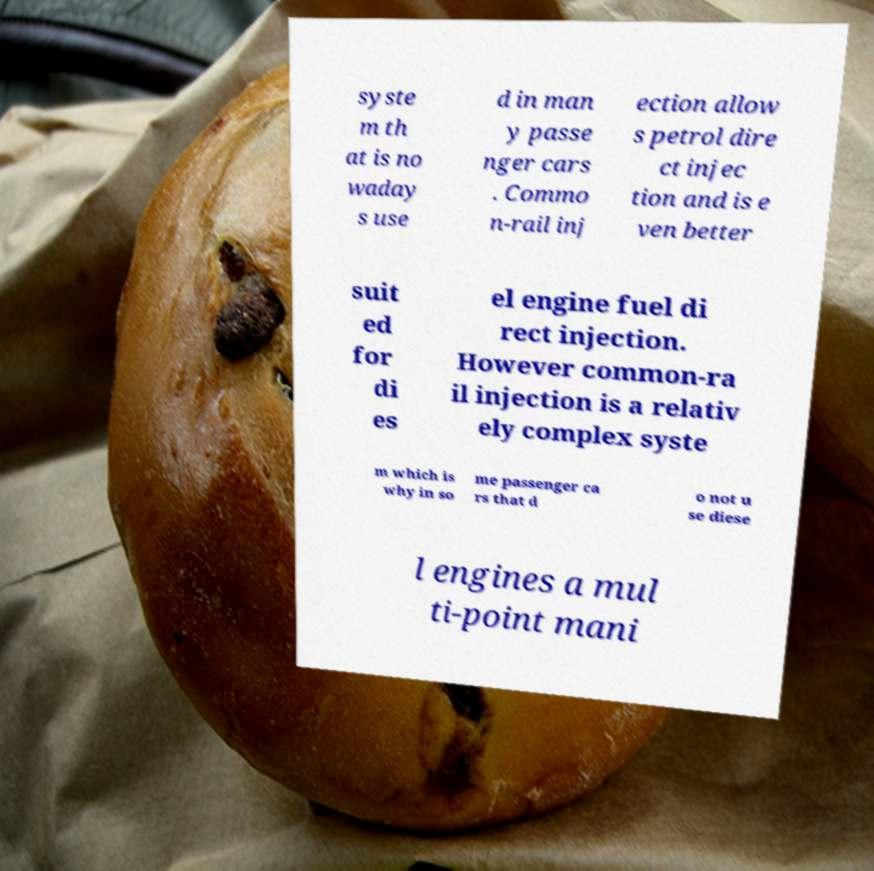Please read and relay the text visible in this image. What does it say? syste m th at is no waday s use d in man y passe nger cars . Commo n-rail inj ection allow s petrol dire ct injec tion and is e ven better suit ed for di es el engine fuel di rect injection. However common-ra il injection is a relativ ely complex syste m which is why in so me passenger ca rs that d o not u se diese l engines a mul ti-point mani 